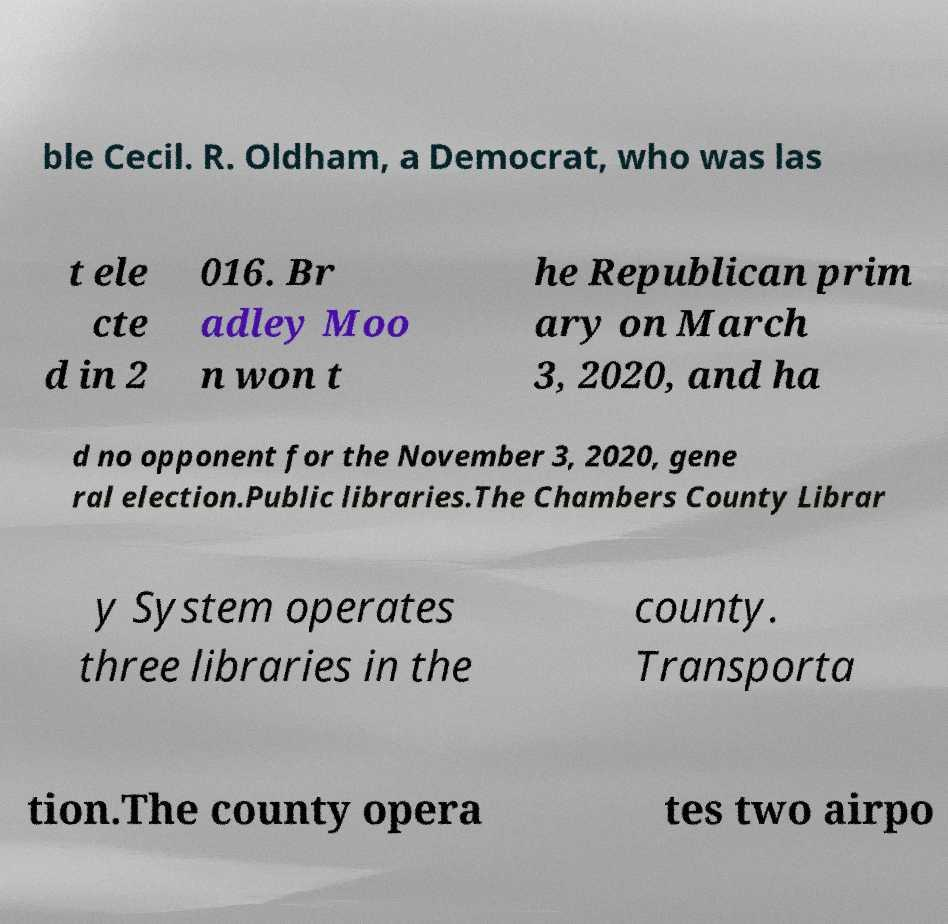For documentation purposes, I need the text within this image transcribed. Could you provide that? ble Cecil. R. Oldham, a Democrat, who was las t ele cte d in 2 016. Br adley Moo n won t he Republican prim ary on March 3, 2020, and ha d no opponent for the November 3, 2020, gene ral election.Public libraries.The Chambers County Librar y System operates three libraries in the county. Transporta tion.The county opera tes two airpo 